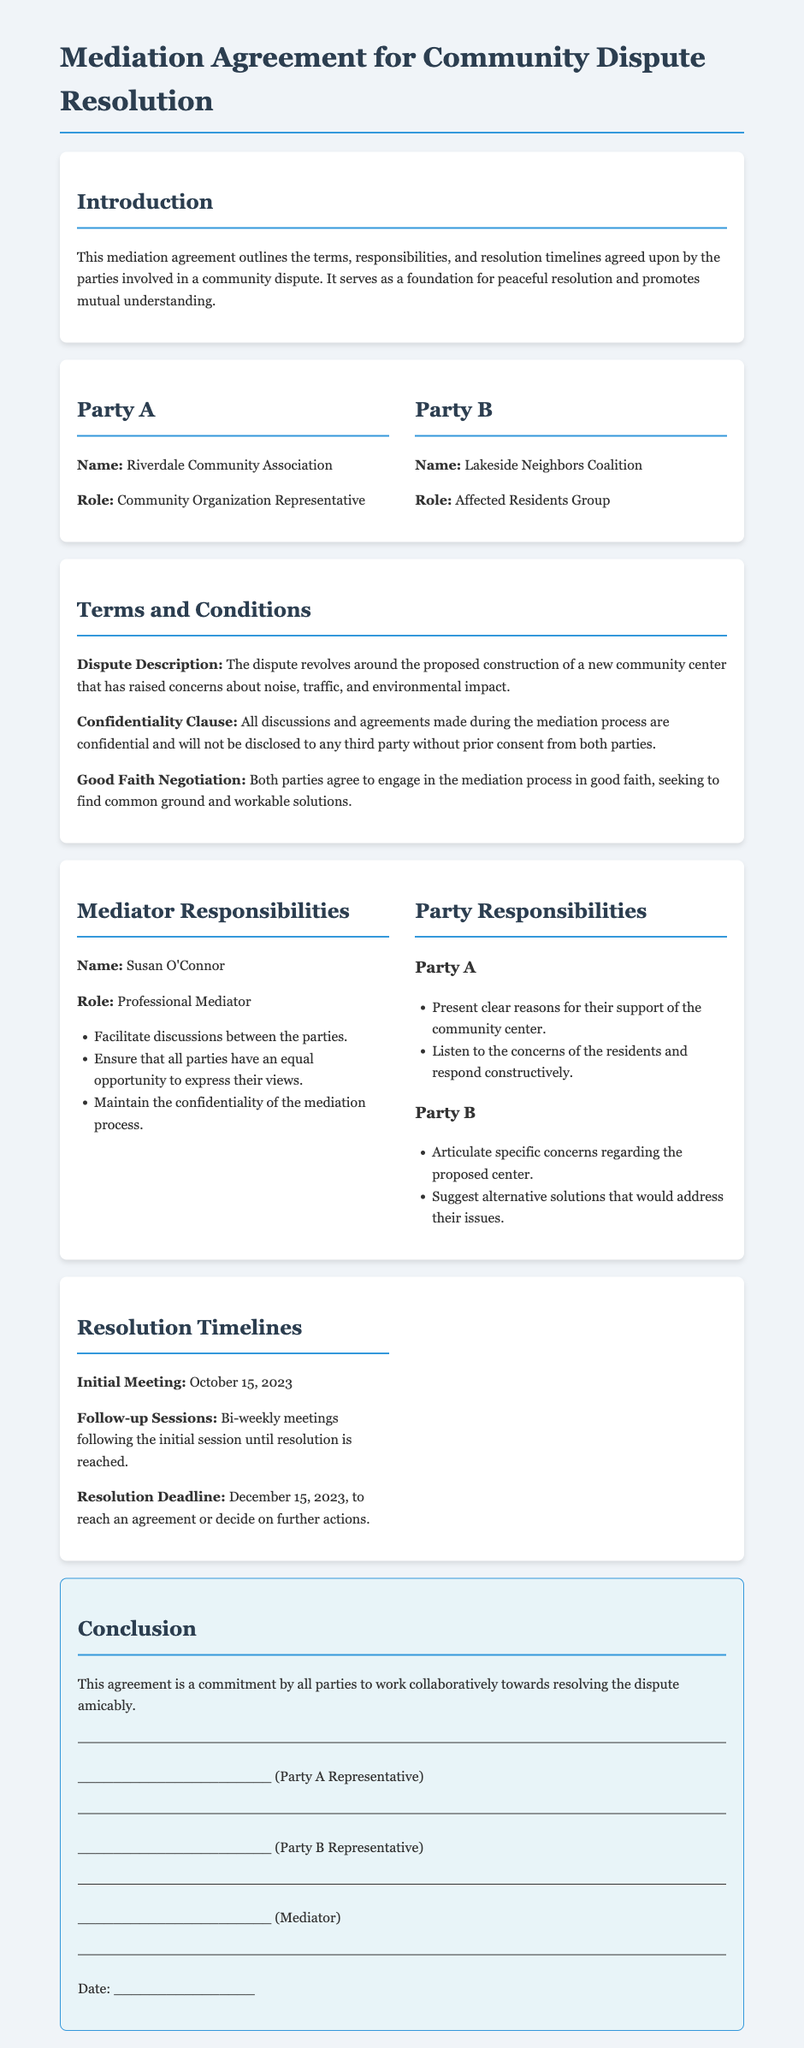What is the name of Party A? Party A is specified as the Riverdale Community Association in the document.
Answer: Riverdale Community Association What is the role of Party B? The role of Party B is defined as the Affected Residents Group in the context of the dispute.
Answer: Affected Residents Group What is the dispute about? The document describes the dispute concerning the proposed construction of a new community center and its potential impacts.
Answer: Proposed construction of a new community center Who is the mediator? The document names Susan O'Connor as the mediator for this mediation agreement.
Answer: Susan O'Connor When is the resolution deadline? The document indicates that the resolution deadline to reach an agreement is December 15, 2023.
Answer: December 15, 2023 What is a responsibility of Party A? The document lists that Party A should present clear reasons for their support of the community center.
Answer: Present clear reasons for their support How often will follow-up sessions be held? The document states that follow-up sessions will occur bi-weekly after the initial meeting until the resolution is reached.
Answer: Bi-weekly What is included in the confidentiality clause? The confidentiality clause stipulates that all discussions and agreements made during the mediation are confidential.
Answer: Confidential discussions and agreements What is the initial meeting date? The document specifies that the initial meeting is scheduled for October 15, 2023.
Answer: October 15, 2023 